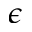Convert formula to latex. <formula><loc_0><loc_0><loc_500><loc_500>\epsilon</formula> 